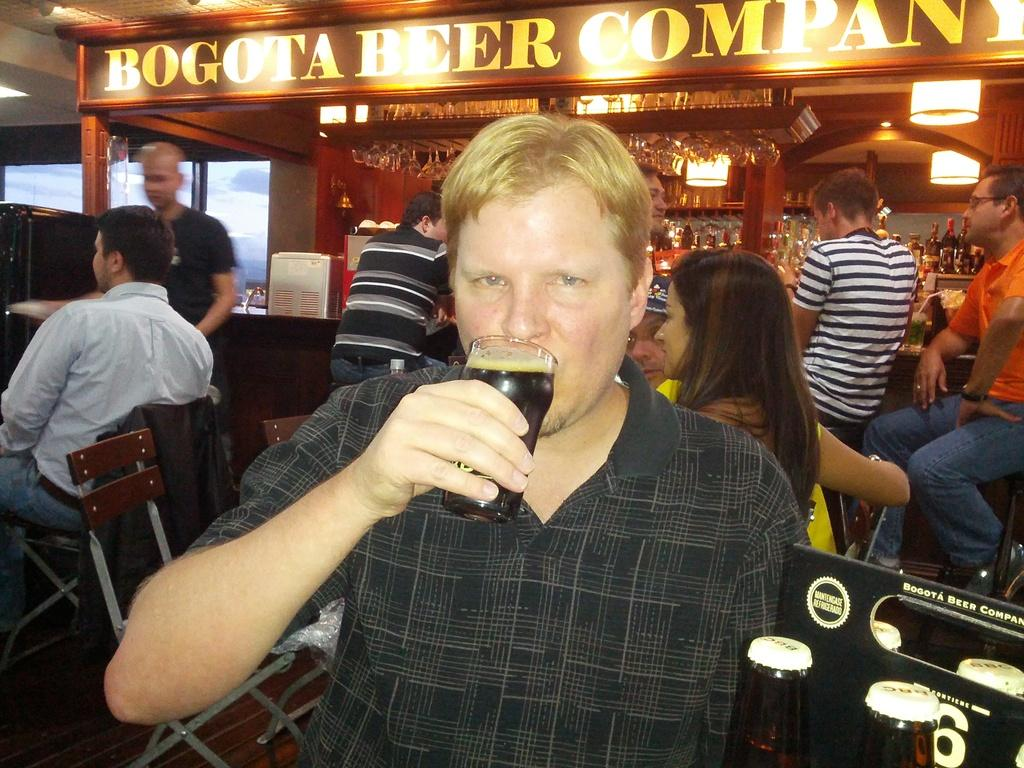What is the person in the image doing with a glass? The person is drinking from a glass. What else can be seen in the image besides the person drinking? There are bottles, people, a board, lights, glasses, and other unspecified things in the image. Can you describe the background of the image? There are glass windows in the background. What are some people doing in the image? Some people are sitting on chairs. What type of question can be heard being asked in the image? There is no indication of a question being asked in the image. Can you describe the sound of thunder in the image? There is no mention of thunder or any sound in the image. 